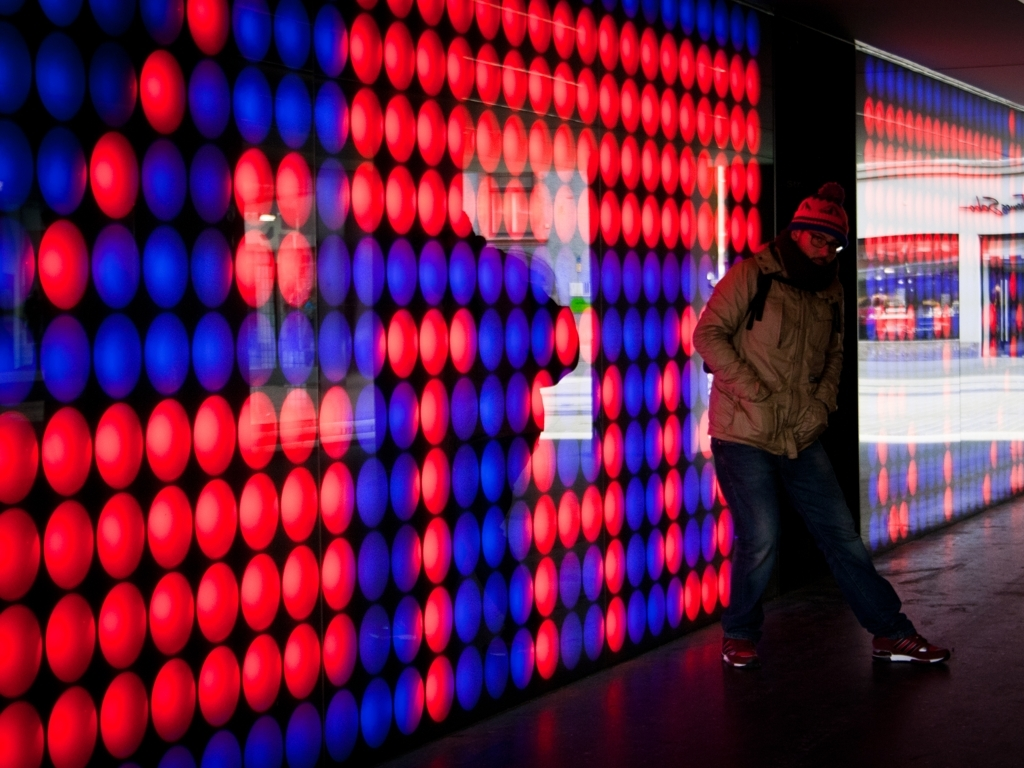What is the dominant color scheme in this image? The dominant color scheme in the image is a combination of red and blue, which creates a vibrant contrast and energizes the scene. Does the lighting have a special meaning or contribute to a certain atmosphere? The interplay of lights creates a futuristic and dynamic ambiance, possibly hinting at the energy of an urban setting or a lively event. 